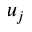Convert formula to latex. <formula><loc_0><loc_0><loc_500><loc_500>u _ { j }</formula> 